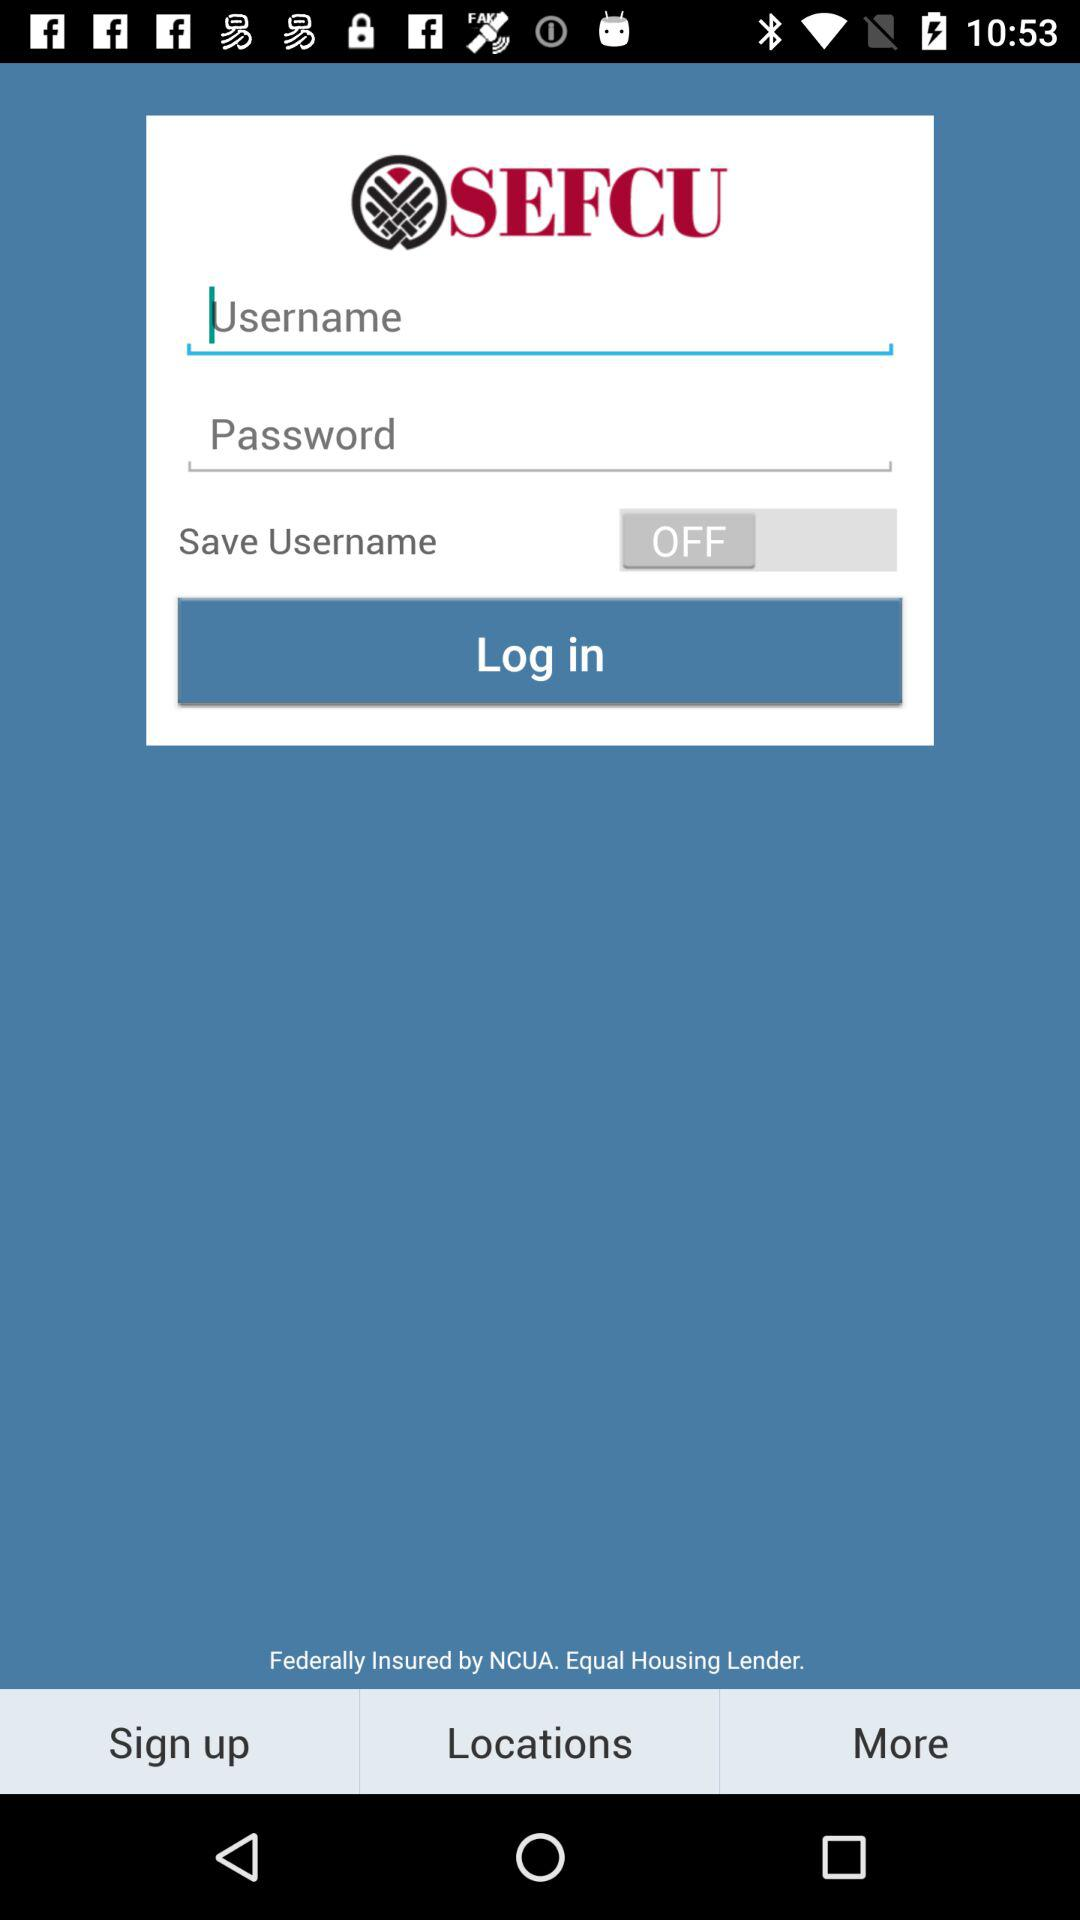What is the name of the application? The name of the application is "SEFCU". 